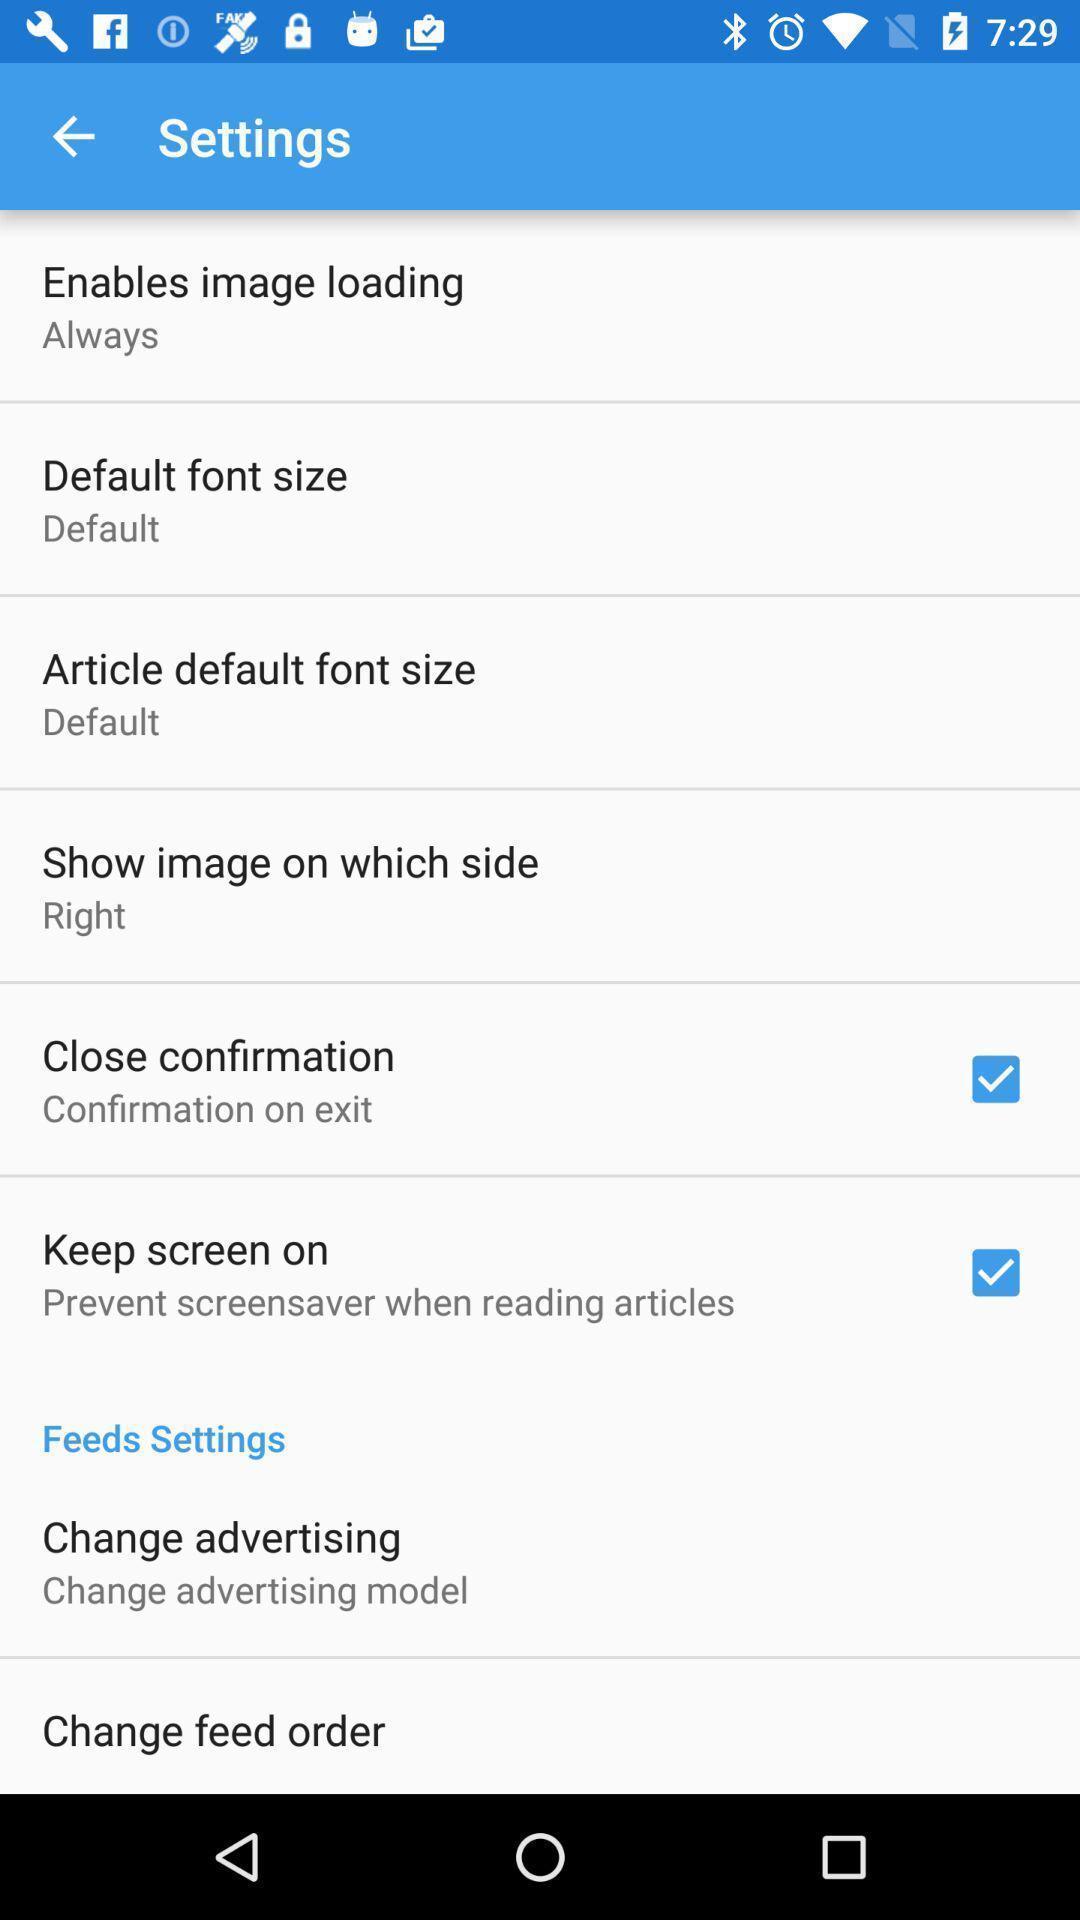Please provide a description for this image. Settings page. 